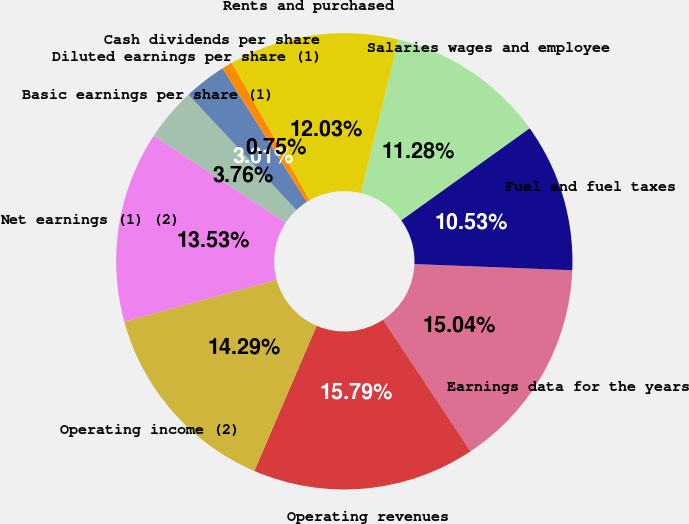Convert chart. <chart><loc_0><loc_0><loc_500><loc_500><pie_chart><fcel>Earnings data for the years<fcel>Operating revenues<fcel>Operating income (2)<fcel>Net earnings (1) (2)<fcel>Basic earnings per share (1)<fcel>Diluted earnings per share (1)<fcel>Cash dividends per share<fcel>Rents and purchased<fcel>Salaries wages and employee<fcel>Fuel and fuel taxes<nl><fcel>15.04%<fcel>15.79%<fcel>14.29%<fcel>13.53%<fcel>3.76%<fcel>3.01%<fcel>0.75%<fcel>12.03%<fcel>11.28%<fcel>10.53%<nl></chart> 